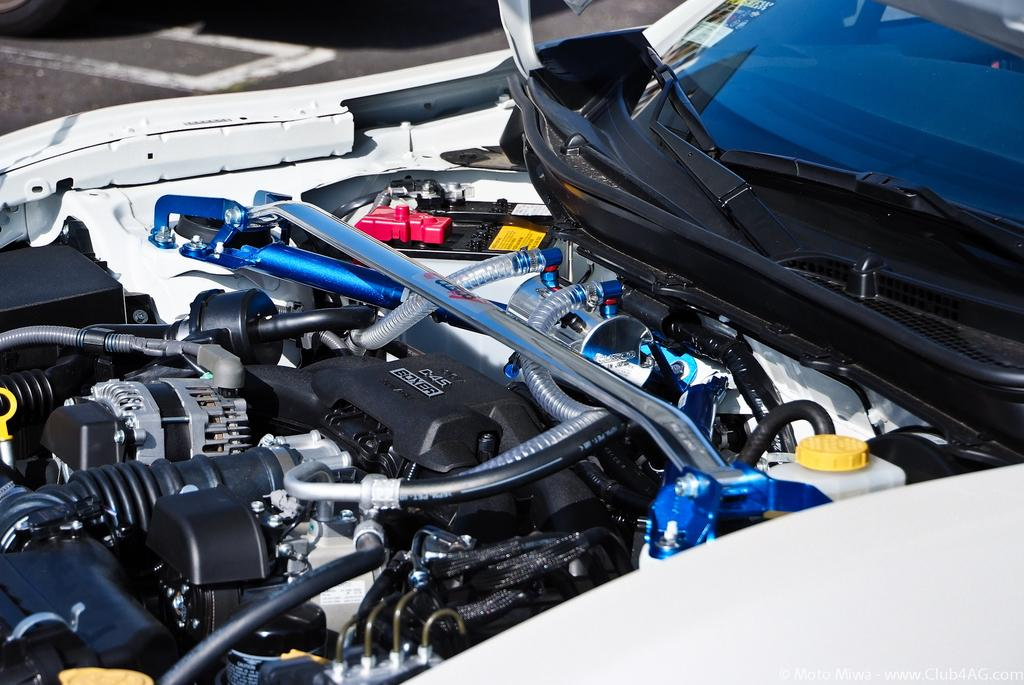What is the main subject of the image? The main subject of the image is a car engine. What specific components can be seen in the image? There is a pipe and a rod in the image. Are there any other objects visible in the image? Yes, there are objects in the image. What additional car-related features can be seen in the image? There is a windshield and a car wiper in the image. What type of selection process is being used to choose the best chain for the car engine in the image? There is no selection process or chain present in the image; it is a static image of a car engine with specific components and features. 